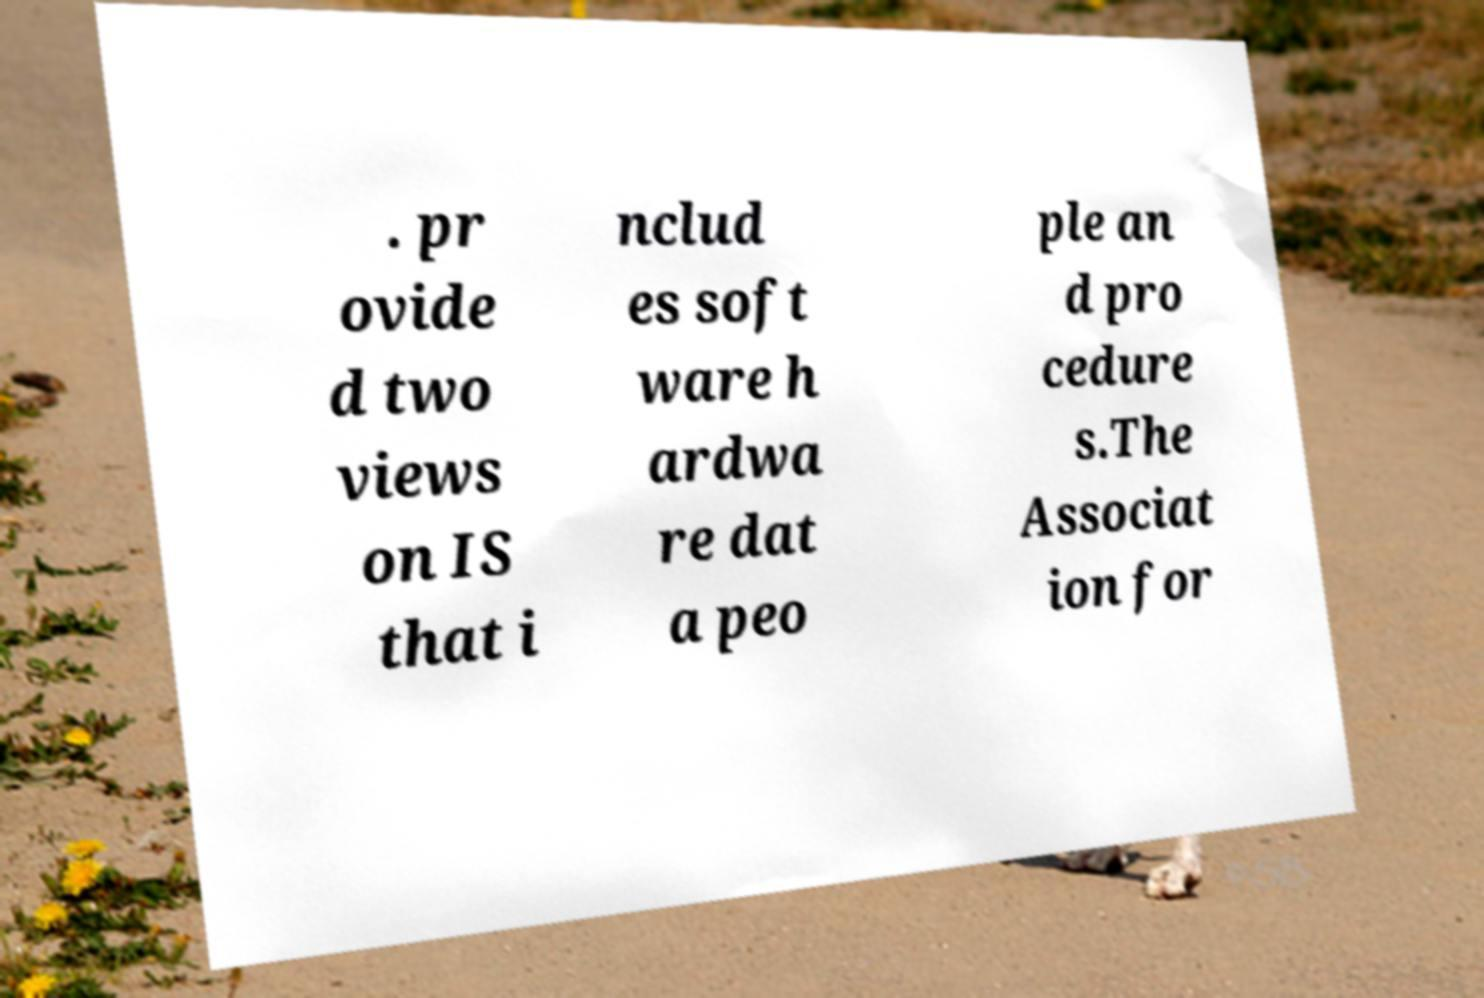Could you extract and type out the text from this image? . pr ovide d two views on IS that i nclud es soft ware h ardwa re dat a peo ple an d pro cedure s.The Associat ion for 